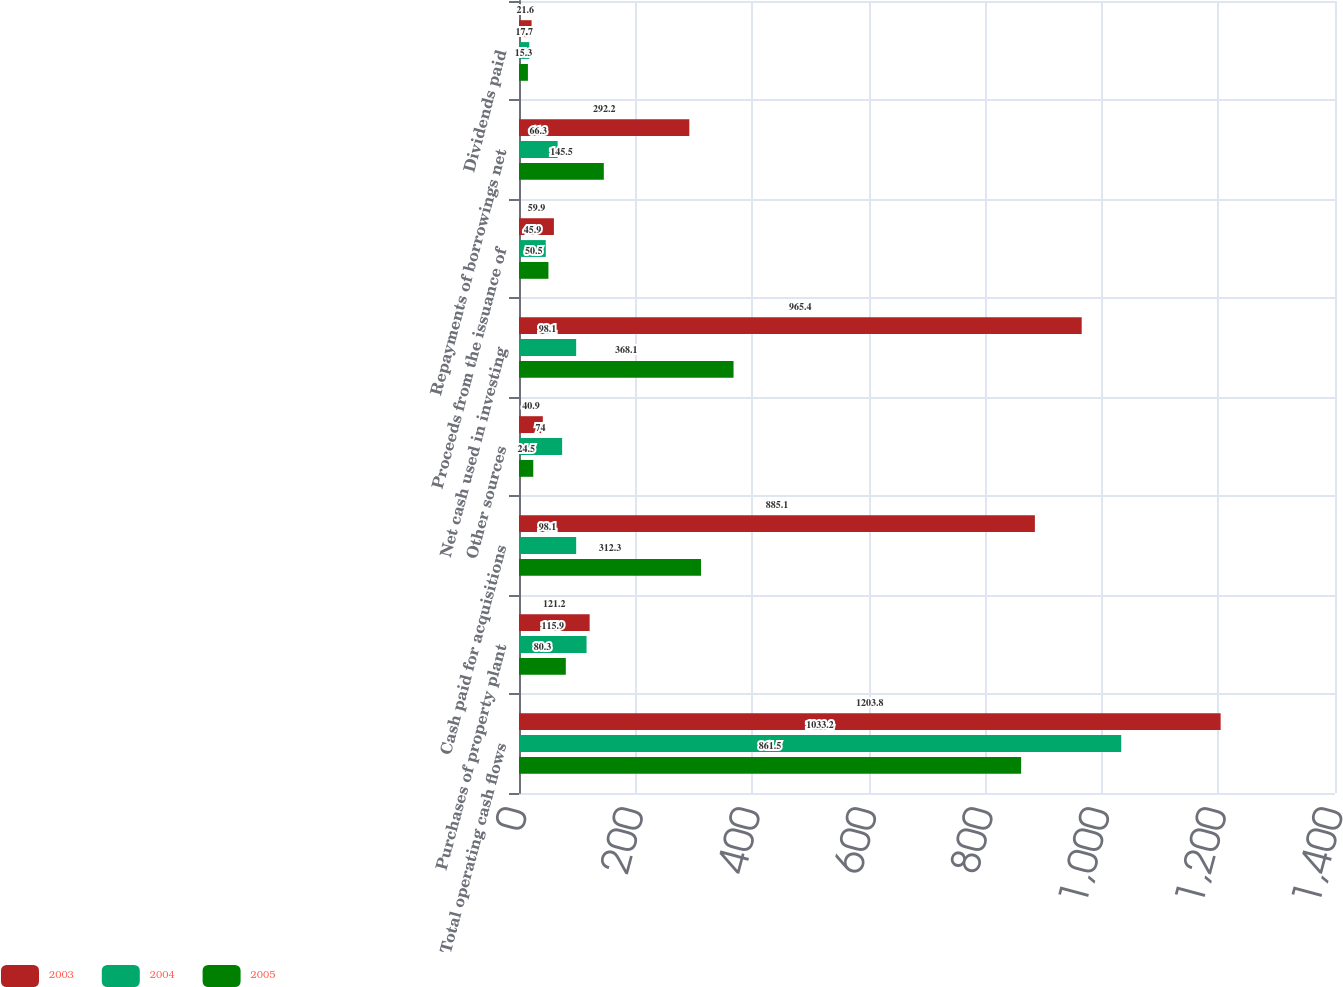Convert chart to OTSL. <chart><loc_0><loc_0><loc_500><loc_500><stacked_bar_chart><ecel><fcel>Total operating cash flows<fcel>Purchases of property plant<fcel>Cash paid for acquisitions<fcel>Other sources<fcel>Net cash used in investing<fcel>Proceeds from the issuance of<fcel>Repayments of borrowings net<fcel>Dividends paid<nl><fcel>2003<fcel>1203.8<fcel>121.2<fcel>885.1<fcel>40.9<fcel>965.4<fcel>59.9<fcel>292.2<fcel>21.6<nl><fcel>2004<fcel>1033.2<fcel>115.9<fcel>98.1<fcel>74<fcel>98.1<fcel>45.9<fcel>66.3<fcel>17.7<nl><fcel>2005<fcel>861.5<fcel>80.3<fcel>312.3<fcel>24.5<fcel>368.1<fcel>50.5<fcel>145.5<fcel>15.3<nl></chart> 